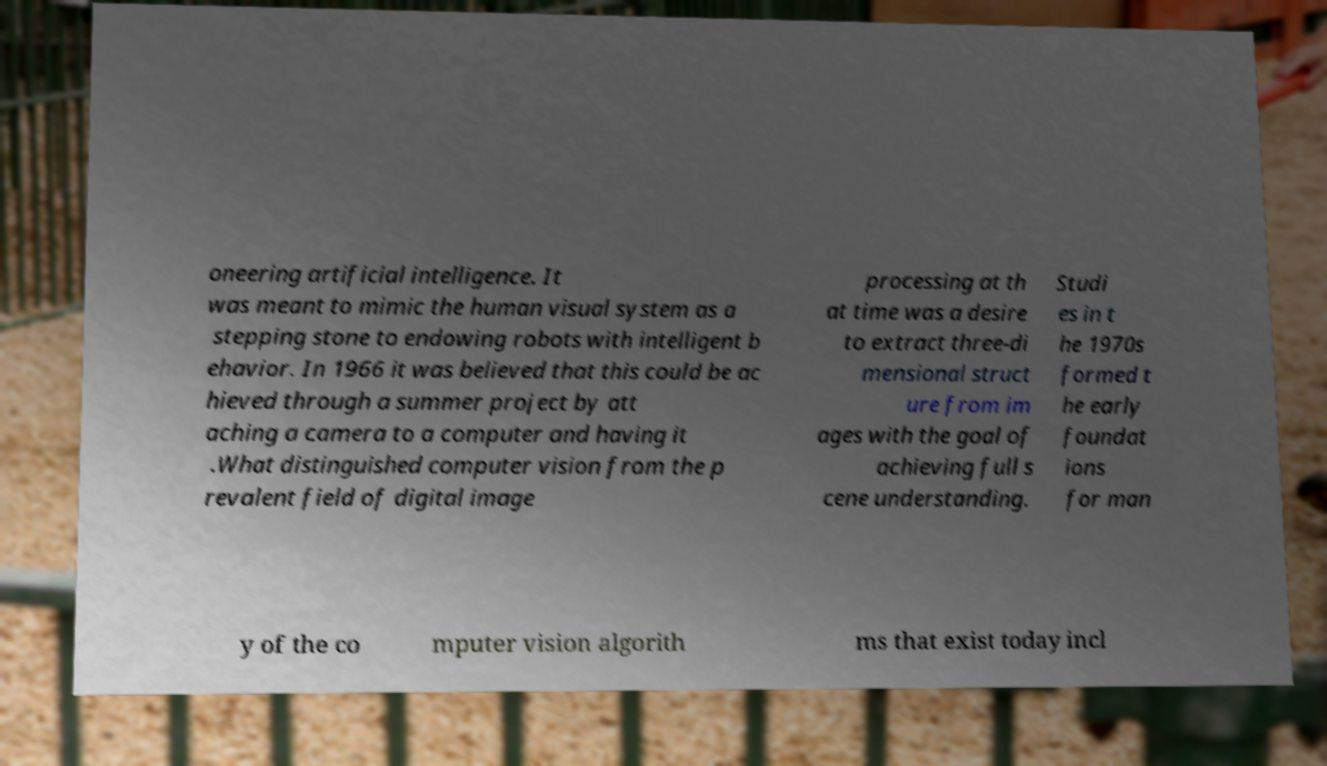Could you assist in decoding the text presented in this image and type it out clearly? oneering artificial intelligence. It was meant to mimic the human visual system as a stepping stone to endowing robots with intelligent b ehavior. In 1966 it was believed that this could be ac hieved through a summer project by att aching a camera to a computer and having it .What distinguished computer vision from the p revalent field of digital image processing at th at time was a desire to extract three-di mensional struct ure from im ages with the goal of achieving full s cene understanding. Studi es in t he 1970s formed t he early foundat ions for man y of the co mputer vision algorith ms that exist today incl 